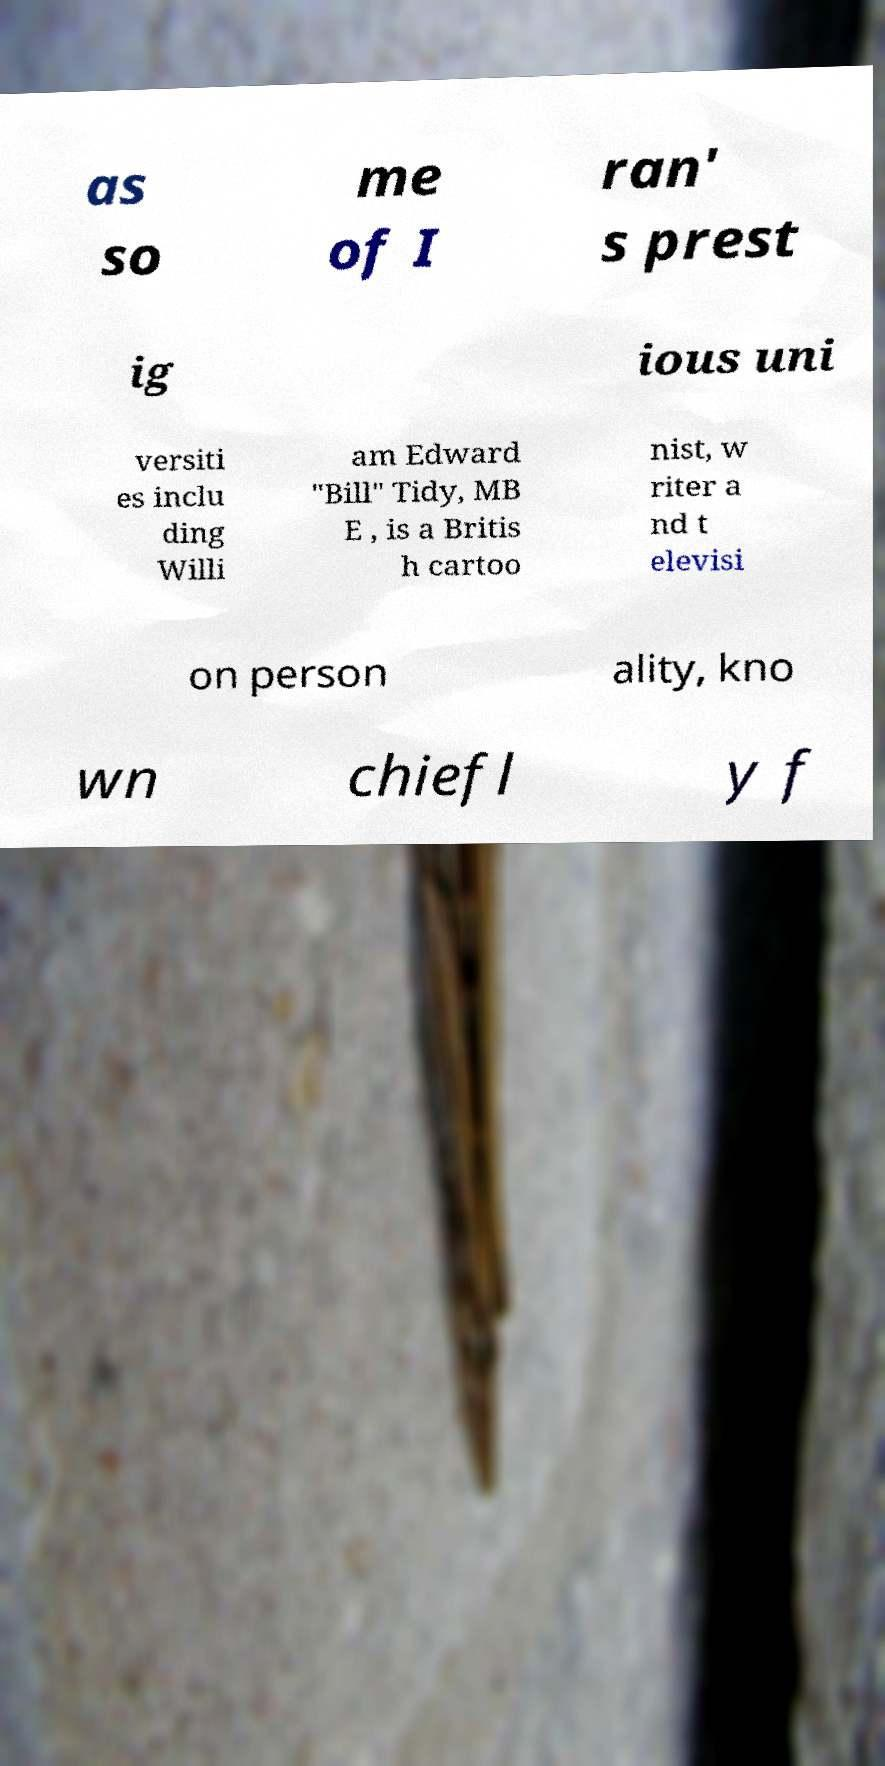What messages or text are displayed in this image? I need them in a readable, typed format. as so me of I ran' s prest ig ious uni versiti es inclu ding Willi am Edward "Bill" Tidy, MB E , is a Britis h cartoo nist, w riter a nd t elevisi on person ality, kno wn chiefl y f 